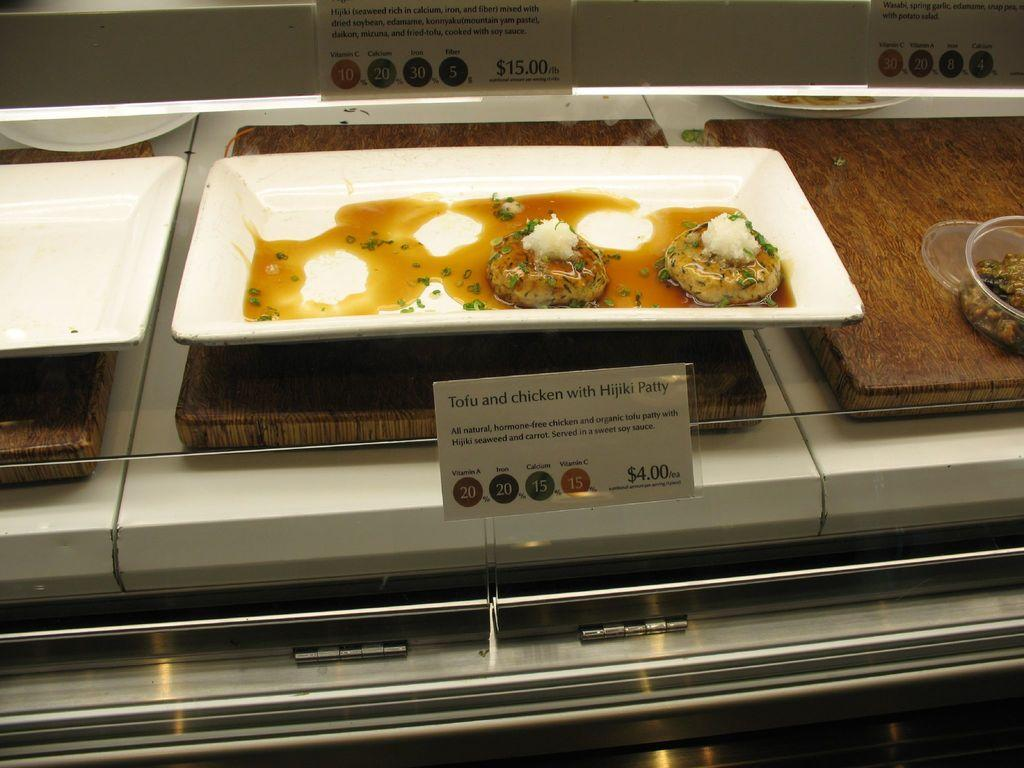What is on the plate that is visible in the image? There is food placed on a plate in the image. What else can be seen on the right side of the image? There is a bowl on the right side of the image. Can you identify any additional information about the items in the image? Yes, there is a price tag visible in the image. What type of doctor is examining the food in the image? There is no doctor present in the image, and the food is not being examined by anyone. 